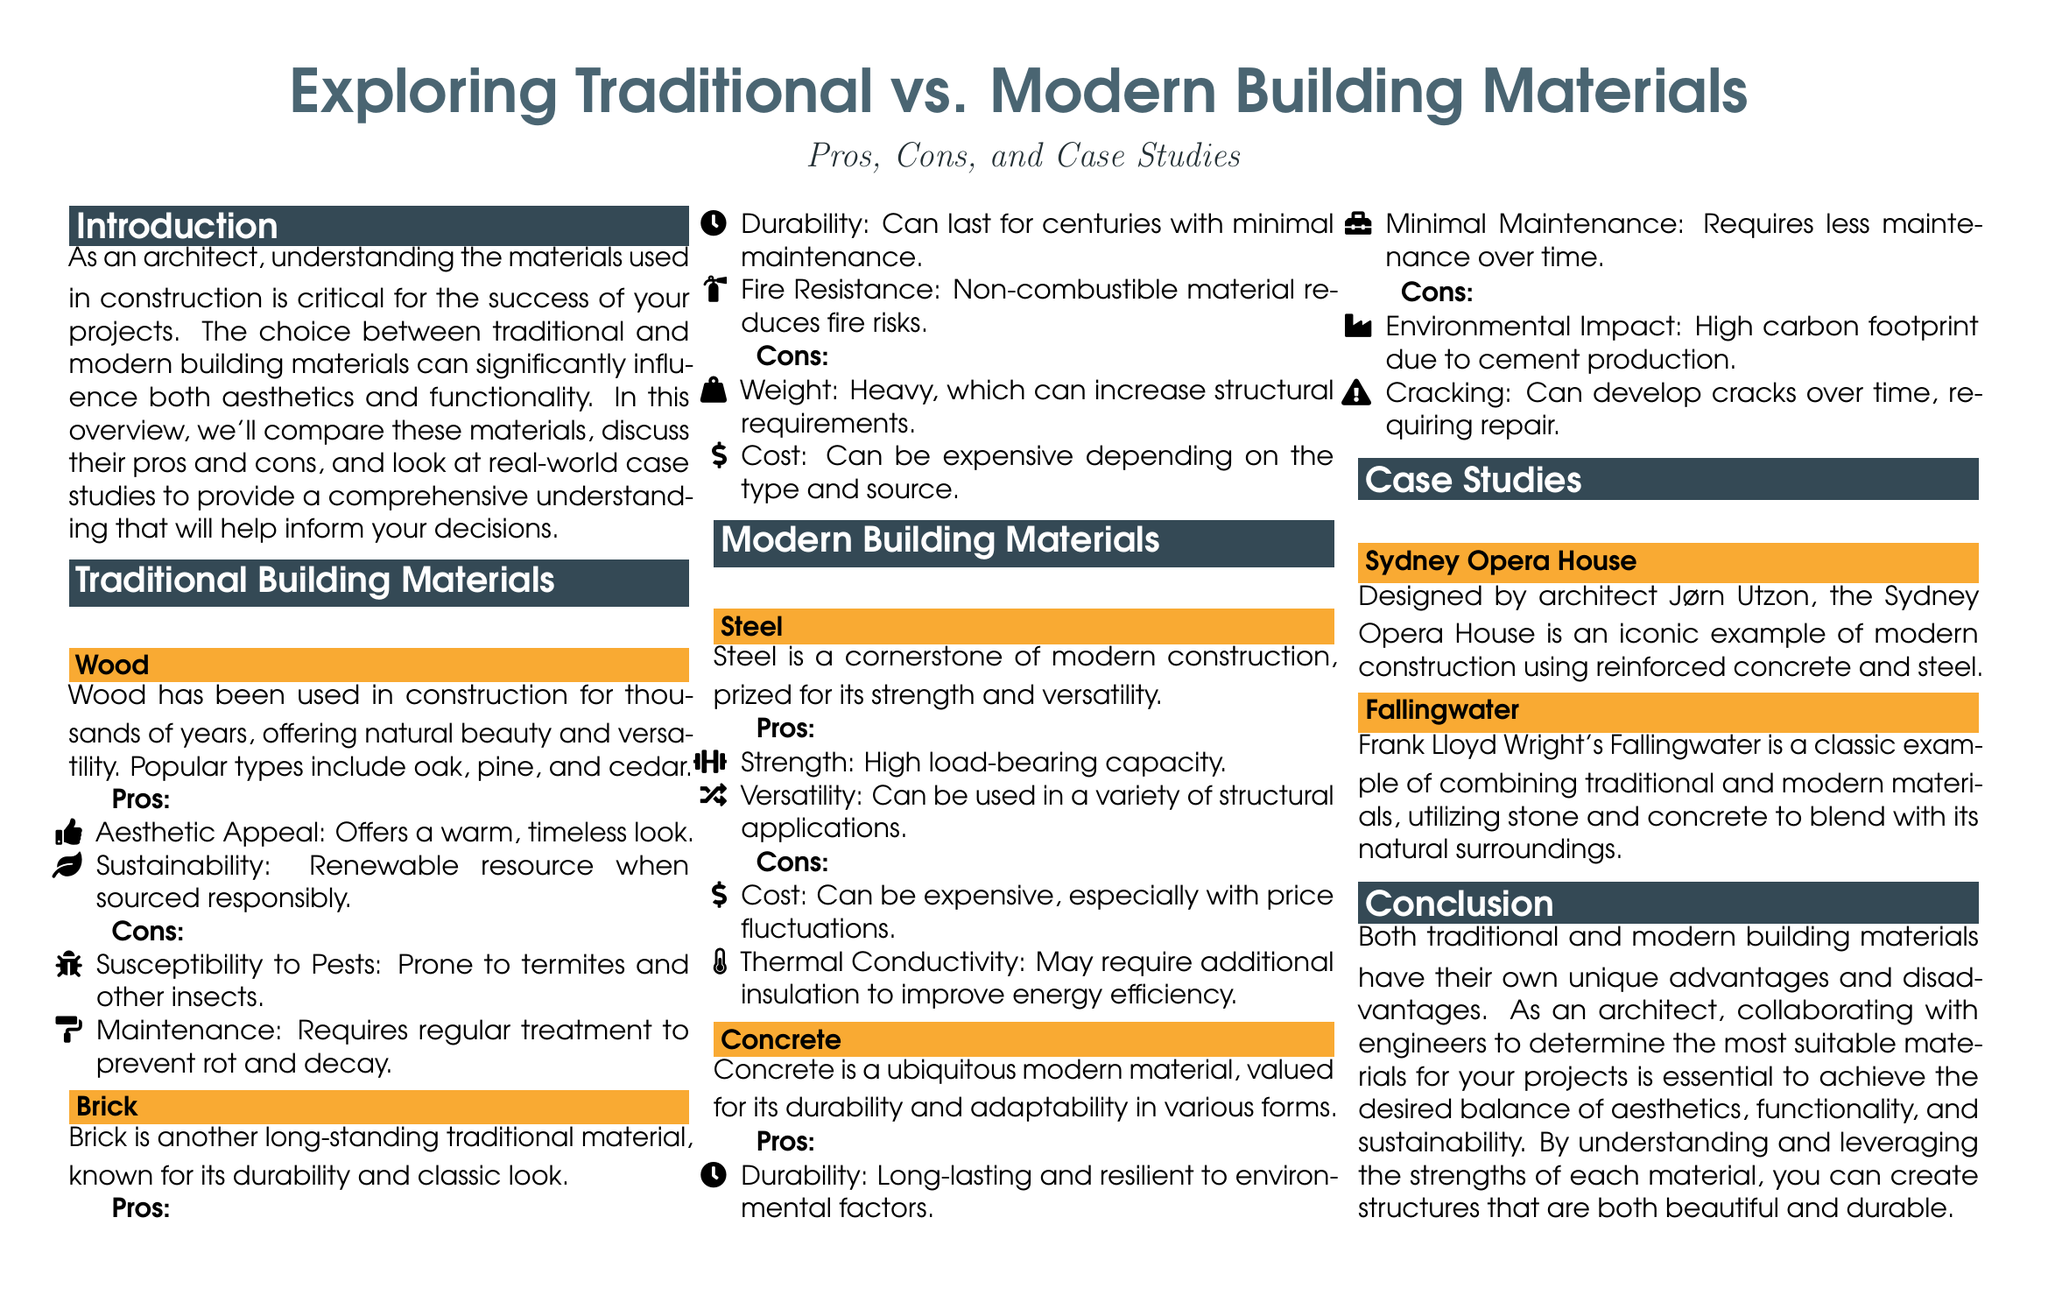What is the main focus of the document? The document provides an overview comparing traditional and modern building materials, discussing their pros and cons along with case studies.
Answer: Traditional vs. Modern Building Materials What are two types of traditional building materials mentioned? The document lists wood and brick as examples of traditional building materials.
Answer: Wood, Brick What is one pro of using steel in construction? The document states that steel has a high load-bearing capacity, making it a strong material for construction.
Answer: Strength What case study features a combination of traditional and modern materials? The document mentions Fallingwater as a case study that combines traditional and modern materials.
Answer: Fallingwater What is a con of using concrete? The document highlights that concrete can develop cracks over time, which can necessitate repairs.
Answer: Cracking What type of material is primarily used in the Sydney Opera House? The Sydney Opera House primarily utilizes reinforced concrete and steel in its construction.
Answer: Reinforced concrete and steel What is a pro of using brick? The document notes that brick can last for centuries with minimal maintenance.
Answer: Durability How does the document suggest an architect should approach material selection? It emphasizes the importance of collaborating with engineers to choose suitable materials that balance aesthetics, functionality, and sustainability.
Answer: Collaborating with engineers What is one environmental concern related to concrete? The document points out that concrete has a high carbon footprint due to cement production, raising environmental concerns.
Answer: High carbon footprint 